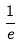Convert formula to latex. <formula><loc_0><loc_0><loc_500><loc_500>\frac { 1 } { e }</formula> 